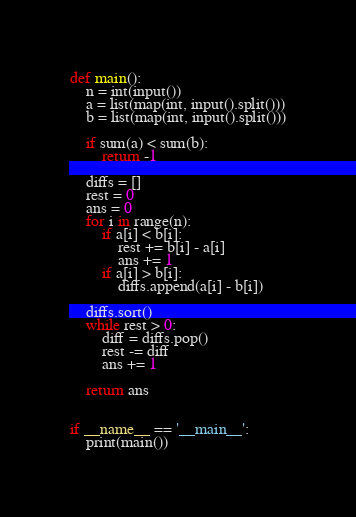Convert code to text. <code><loc_0><loc_0><loc_500><loc_500><_Python_>def main():
    n = int(input())
    a = list(map(int, input().split()))
    b = list(map(int, input().split()))

    if sum(a) < sum(b):
        return -1

    diffs = []
    rest = 0
    ans = 0
    for i in range(n):
        if a[i] < b[i]:
            rest += b[i] - a[i]
            ans += 1
        if a[i] > b[i]:
            diffs.append(a[i] - b[i])
            
    diffs.sort()
    while rest > 0:
        diff = diffs.pop()
        rest -= diff
        ans += 1

    return ans


if __name__ == '__main__':
    print(main())</code> 